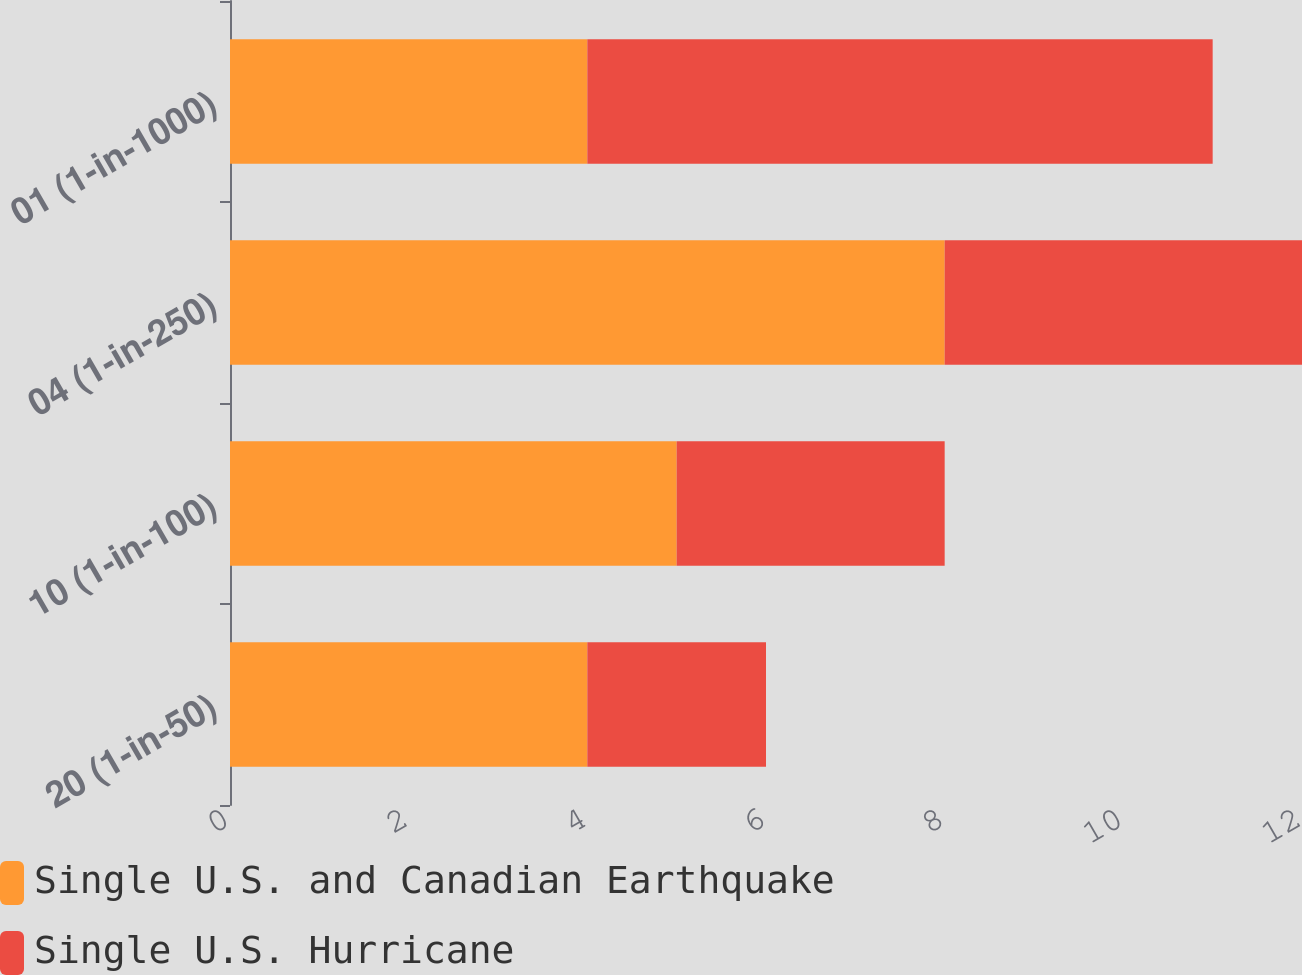Convert chart. <chart><loc_0><loc_0><loc_500><loc_500><stacked_bar_chart><ecel><fcel>20 (1-in-50)<fcel>10 (1-in-100)<fcel>04 (1-in-250)<fcel>01 (1-in-1000)<nl><fcel>Single U.S. and Canadian Earthquake<fcel>4<fcel>5<fcel>8<fcel>4<nl><fcel>Single U.S. Hurricane<fcel>2<fcel>3<fcel>4<fcel>7<nl></chart> 